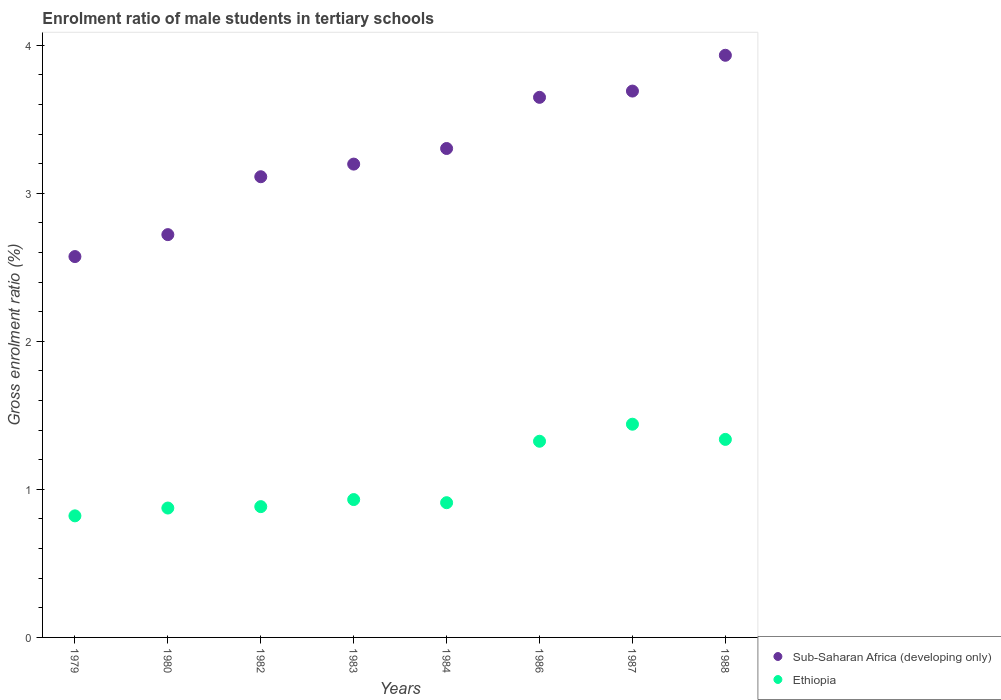How many different coloured dotlines are there?
Provide a short and direct response. 2. What is the enrolment ratio of male students in tertiary schools in Sub-Saharan Africa (developing only) in 1980?
Give a very brief answer. 2.72. Across all years, what is the maximum enrolment ratio of male students in tertiary schools in Sub-Saharan Africa (developing only)?
Keep it short and to the point. 3.93. Across all years, what is the minimum enrolment ratio of male students in tertiary schools in Ethiopia?
Offer a very short reply. 0.82. In which year was the enrolment ratio of male students in tertiary schools in Sub-Saharan Africa (developing only) maximum?
Your answer should be compact. 1988. In which year was the enrolment ratio of male students in tertiary schools in Ethiopia minimum?
Your response must be concise. 1979. What is the total enrolment ratio of male students in tertiary schools in Sub-Saharan Africa (developing only) in the graph?
Give a very brief answer. 26.18. What is the difference between the enrolment ratio of male students in tertiary schools in Sub-Saharan Africa (developing only) in 1980 and that in 1986?
Provide a succinct answer. -0.93. What is the difference between the enrolment ratio of male students in tertiary schools in Ethiopia in 1980 and the enrolment ratio of male students in tertiary schools in Sub-Saharan Africa (developing only) in 1982?
Ensure brevity in your answer.  -2.24. What is the average enrolment ratio of male students in tertiary schools in Sub-Saharan Africa (developing only) per year?
Ensure brevity in your answer.  3.27. In the year 1986, what is the difference between the enrolment ratio of male students in tertiary schools in Sub-Saharan Africa (developing only) and enrolment ratio of male students in tertiary schools in Ethiopia?
Give a very brief answer. 2.32. What is the ratio of the enrolment ratio of male students in tertiary schools in Sub-Saharan Africa (developing only) in 1980 to that in 1986?
Provide a succinct answer. 0.75. Is the difference between the enrolment ratio of male students in tertiary schools in Sub-Saharan Africa (developing only) in 1983 and 1987 greater than the difference between the enrolment ratio of male students in tertiary schools in Ethiopia in 1983 and 1987?
Provide a succinct answer. Yes. What is the difference between the highest and the second highest enrolment ratio of male students in tertiary schools in Ethiopia?
Give a very brief answer. 0.1. What is the difference between the highest and the lowest enrolment ratio of male students in tertiary schools in Sub-Saharan Africa (developing only)?
Offer a terse response. 1.36. Does the enrolment ratio of male students in tertiary schools in Sub-Saharan Africa (developing only) monotonically increase over the years?
Offer a very short reply. Yes. Is the enrolment ratio of male students in tertiary schools in Ethiopia strictly greater than the enrolment ratio of male students in tertiary schools in Sub-Saharan Africa (developing only) over the years?
Offer a terse response. No. How many dotlines are there?
Provide a succinct answer. 2. How many years are there in the graph?
Ensure brevity in your answer.  8. What is the difference between two consecutive major ticks on the Y-axis?
Provide a succinct answer. 1. Does the graph contain any zero values?
Keep it short and to the point. No. Does the graph contain grids?
Offer a very short reply. No. Where does the legend appear in the graph?
Provide a short and direct response. Bottom right. How many legend labels are there?
Offer a very short reply. 2. How are the legend labels stacked?
Keep it short and to the point. Vertical. What is the title of the graph?
Ensure brevity in your answer.  Enrolment ratio of male students in tertiary schools. Does "Cuba" appear as one of the legend labels in the graph?
Offer a terse response. No. What is the label or title of the X-axis?
Your answer should be very brief. Years. What is the Gross enrolment ratio (%) in Sub-Saharan Africa (developing only) in 1979?
Ensure brevity in your answer.  2.57. What is the Gross enrolment ratio (%) in Ethiopia in 1979?
Provide a short and direct response. 0.82. What is the Gross enrolment ratio (%) of Sub-Saharan Africa (developing only) in 1980?
Provide a short and direct response. 2.72. What is the Gross enrolment ratio (%) of Ethiopia in 1980?
Make the answer very short. 0.87. What is the Gross enrolment ratio (%) of Sub-Saharan Africa (developing only) in 1982?
Your answer should be compact. 3.11. What is the Gross enrolment ratio (%) of Ethiopia in 1982?
Offer a terse response. 0.88. What is the Gross enrolment ratio (%) in Sub-Saharan Africa (developing only) in 1983?
Keep it short and to the point. 3.2. What is the Gross enrolment ratio (%) in Ethiopia in 1983?
Your response must be concise. 0.93. What is the Gross enrolment ratio (%) in Sub-Saharan Africa (developing only) in 1984?
Ensure brevity in your answer.  3.3. What is the Gross enrolment ratio (%) of Ethiopia in 1984?
Your answer should be very brief. 0.91. What is the Gross enrolment ratio (%) in Sub-Saharan Africa (developing only) in 1986?
Ensure brevity in your answer.  3.65. What is the Gross enrolment ratio (%) of Ethiopia in 1986?
Offer a very short reply. 1.33. What is the Gross enrolment ratio (%) of Sub-Saharan Africa (developing only) in 1987?
Ensure brevity in your answer.  3.69. What is the Gross enrolment ratio (%) in Ethiopia in 1987?
Give a very brief answer. 1.44. What is the Gross enrolment ratio (%) of Sub-Saharan Africa (developing only) in 1988?
Offer a very short reply. 3.93. What is the Gross enrolment ratio (%) of Ethiopia in 1988?
Keep it short and to the point. 1.34. Across all years, what is the maximum Gross enrolment ratio (%) of Sub-Saharan Africa (developing only)?
Provide a succinct answer. 3.93. Across all years, what is the maximum Gross enrolment ratio (%) in Ethiopia?
Offer a terse response. 1.44. Across all years, what is the minimum Gross enrolment ratio (%) of Sub-Saharan Africa (developing only)?
Ensure brevity in your answer.  2.57. Across all years, what is the minimum Gross enrolment ratio (%) of Ethiopia?
Give a very brief answer. 0.82. What is the total Gross enrolment ratio (%) in Sub-Saharan Africa (developing only) in the graph?
Offer a very short reply. 26.18. What is the total Gross enrolment ratio (%) of Ethiopia in the graph?
Offer a terse response. 8.52. What is the difference between the Gross enrolment ratio (%) of Sub-Saharan Africa (developing only) in 1979 and that in 1980?
Offer a very short reply. -0.15. What is the difference between the Gross enrolment ratio (%) of Ethiopia in 1979 and that in 1980?
Offer a very short reply. -0.05. What is the difference between the Gross enrolment ratio (%) of Sub-Saharan Africa (developing only) in 1979 and that in 1982?
Provide a succinct answer. -0.54. What is the difference between the Gross enrolment ratio (%) in Ethiopia in 1979 and that in 1982?
Offer a terse response. -0.06. What is the difference between the Gross enrolment ratio (%) in Sub-Saharan Africa (developing only) in 1979 and that in 1983?
Keep it short and to the point. -0.62. What is the difference between the Gross enrolment ratio (%) of Ethiopia in 1979 and that in 1983?
Ensure brevity in your answer.  -0.11. What is the difference between the Gross enrolment ratio (%) of Sub-Saharan Africa (developing only) in 1979 and that in 1984?
Give a very brief answer. -0.73. What is the difference between the Gross enrolment ratio (%) of Ethiopia in 1979 and that in 1984?
Provide a short and direct response. -0.09. What is the difference between the Gross enrolment ratio (%) of Sub-Saharan Africa (developing only) in 1979 and that in 1986?
Provide a short and direct response. -1.08. What is the difference between the Gross enrolment ratio (%) in Ethiopia in 1979 and that in 1986?
Offer a terse response. -0.5. What is the difference between the Gross enrolment ratio (%) of Sub-Saharan Africa (developing only) in 1979 and that in 1987?
Offer a very short reply. -1.12. What is the difference between the Gross enrolment ratio (%) of Ethiopia in 1979 and that in 1987?
Give a very brief answer. -0.62. What is the difference between the Gross enrolment ratio (%) in Sub-Saharan Africa (developing only) in 1979 and that in 1988?
Ensure brevity in your answer.  -1.36. What is the difference between the Gross enrolment ratio (%) of Ethiopia in 1979 and that in 1988?
Offer a terse response. -0.52. What is the difference between the Gross enrolment ratio (%) of Sub-Saharan Africa (developing only) in 1980 and that in 1982?
Ensure brevity in your answer.  -0.39. What is the difference between the Gross enrolment ratio (%) in Ethiopia in 1980 and that in 1982?
Provide a succinct answer. -0.01. What is the difference between the Gross enrolment ratio (%) of Sub-Saharan Africa (developing only) in 1980 and that in 1983?
Your answer should be compact. -0.48. What is the difference between the Gross enrolment ratio (%) of Ethiopia in 1980 and that in 1983?
Give a very brief answer. -0.06. What is the difference between the Gross enrolment ratio (%) in Sub-Saharan Africa (developing only) in 1980 and that in 1984?
Keep it short and to the point. -0.58. What is the difference between the Gross enrolment ratio (%) of Ethiopia in 1980 and that in 1984?
Give a very brief answer. -0.04. What is the difference between the Gross enrolment ratio (%) in Sub-Saharan Africa (developing only) in 1980 and that in 1986?
Keep it short and to the point. -0.93. What is the difference between the Gross enrolment ratio (%) in Ethiopia in 1980 and that in 1986?
Ensure brevity in your answer.  -0.45. What is the difference between the Gross enrolment ratio (%) of Sub-Saharan Africa (developing only) in 1980 and that in 1987?
Your answer should be very brief. -0.97. What is the difference between the Gross enrolment ratio (%) in Ethiopia in 1980 and that in 1987?
Your response must be concise. -0.57. What is the difference between the Gross enrolment ratio (%) of Sub-Saharan Africa (developing only) in 1980 and that in 1988?
Ensure brevity in your answer.  -1.21. What is the difference between the Gross enrolment ratio (%) of Ethiopia in 1980 and that in 1988?
Offer a terse response. -0.46. What is the difference between the Gross enrolment ratio (%) of Sub-Saharan Africa (developing only) in 1982 and that in 1983?
Provide a short and direct response. -0.09. What is the difference between the Gross enrolment ratio (%) of Ethiopia in 1982 and that in 1983?
Ensure brevity in your answer.  -0.05. What is the difference between the Gross enrolment ratio (%) of Sub-Saharan Africa (developing only) in 1982 and that in 1984?
Your answer should be compact. -0.19. What is the difference between the Gross enrolment ratio (%) of Ethiopia in 1982 and that in 1984?
Keep it short and to the point. -0.03. What is the difference between the Gross enrolment ratio (%) of Sub-Saharan Africa (developing only) in 1982 and that in 1986?
Offer a very short reply. -0.54. What is the difference between the Gross enrolment ratio (%) in Ethiopia in 1982 and that in 1986?
Provide a succinct answer. -0.44. What is the difference between the Gross enrolment ratio (%) in Sub-Saharan Africa (developing only) in 1982 and that in 1987?
Provide a succinct answer. -0.58. What is the difference between the Gross enrolment ratio (%) of Ethiopia in 1982 and that in 1987?
Provide a short and direct response. -0.56. What is the difference between the Gross enrolment ratio (%) in Sub-Saharan Africa (developing only) in 1982 and that in 1988?
Your answer should be compact. -0.82. What is the difference between the Gross enrolment ratio (%) of Ethiopia in 1982 and that in 1988?
Keep it short and to the point. -0.45. What is the difference between the Gross enrolment ratio (%) in Sub-Saharan Africa (developing only) in 1983 and that in 1984?
Provide a short and direct response. -0.11. What is the difference between the Gross enrolment ratio (%) of Ethiopia in 1983 and that in 1984?
Your answer should be very brief. 0.02. What is the difference between the Gross enrolment ratio (%) of Sub-Saharan Africa (developing only) in 1983 and that in 1986?
Give a very brief answer. -0.45. What is the difference between the Gross enrolment ratio (%) in Ethiopia in 1983 and that in 1986?
Your answer should be very brief. -0.39. What is the difference between the Gross enrolment ratio (%) in Sub-Saharan Africa (developing only) in 1983 and that in 1987?
Provide a short and direct response. -0.49. What is the difference between the Gross enrolment ratio (%) of Ethiopia in 1983 and that in 1987?
Provide a short and direct response. -0.51. What is the difference between the Gross enrolment ratio (%) of Sub-Saharan Africa (developing only) in 1983 and that in 1988?
Provide a short and direct response. -0.74. What is the difference between the Gross enrolment ratio (%) of Ethiopia in 1983 and that in 1988?
Ensure brevity in your answer.  -0.41. What is the difference between the Gross enrolment ratio (%) in Sub-Saharan Africa (developing only) in 1984 and that in 1986?
Your answer should be compact. -0.35. What is the difference between the Gross enrolment ratio (%) of Ethiopia in 1984 and that in 1986?
Give a very brief answer. -0.42. What is the difference between the Gross enrolment ratio (%) in Sub-Saharan Africa (developing only) in 1984 and that in 1987?
Your answer should be very brief. -0.39. What is the difference between the Gross enrolment ratio (%) in Ethiopia in 1984 and that in 1987?
Keep it short and to the point. -0.53. What is the difference between the Gross enrolment ratio (%) of Sub-Saharan Africa (developing only) in 1984 and that in 1988?
Make the answer very short. -0.63. What is the difference between the Gross enrolment ratio (%) in Ethiopia in 1984 and that in 1988?
Your answer should be very brief. -0.43. What is the difference between the Gross enrolment ratio (%) of Sub-Saharan Africa (developing only) in 1986 and that in 1987?
Give a very brief answer. -0.04. What is the difference between the Gross enrolment ratio (%) of Ethiopia in 1986 and that in 1987?
Your answer should be very brief. -0.12. What is the difference between the Gross enrolment ratio (%) in Sub-Saharan Africa (developing only) in 1986 and that in 1988?
Offer a very short reply. -0.28. What is the difference between the Gross enrolment ratio (%) of Ethiopia in 1986 and that in 1988?
Your answer should be compact. -0.01. What is the difference between the Gross enrolment ratio (%) of Sub-Saharan Africa (developing only) in 1987 and that in 1988?
Provide a succinct answer. -0.24. What is the difference between the Gross enrolment ratio (%) in Ethiopia in 1987 and that in 1988?
Offer a very short reply. 0.1. What is the difference between the Gross enrolment ratio (%) in Sub-Saharan Africa (developing only) in 1979 and the Gross enrolment ratio (%) in Ethiopia in 1980?
Your response must be concise. 1.7. What is the difference between the Gross enrolment ratio (%) of Sub-Saharan Africa (developing only) in 1979 and the Gross enrolment ratio (%) of Ethiopia in 1982?
Make the answer very short. 1.69. What is the difference between the Gross enrolment ratio (%) of Sub-Saharan Africa (developing only) in 1979 and the Gross enrolment ratio (%) of Ethiopia in 1983?
Provide a short and direct response. 1.64. What is the difference between the Gross enrolment ratio (%) in Sub-Saharan Africa (developing only) in 1979 and the Gross enrolment ratio (%) in Ethiopia in 1984?
Keep it short and to the point. 1.66. What is the difference between the Gross enrolment ratio (%) of Sub-Saharan Africa (developing only) in 1979 and the Gross enrolment ratio (%) of Ethiopia in 1986?
Provide a short and direct response. 1.25. What is the difference between the Gross enrolment ratio (%) in Sub-Saharan Africa (developing only) in 1979 and the Gross enrolment ratio (%) in Ethiopia in 1987?
Provide a succinct answer. 1.13. What is the difference between the Gross enrolment ratio (%) of Sub-Saharan Africa (developing only) in 1979 and the Gross enrolment ratio (%) of Ethiopia in 1988?
Your response must be concise. 1.23. What is the difference between the Gross enrolment ratio (%) in Sub-Saharan Africa (developing only) in 1980 and the Gross enrolment ratio (%) in Ethiopia in 1982?
Provide a short and direct response. 1.84. What is the difference between the Gross enrolment ratio (%) in Sub-Saharan Africa (developing only) in 1980 and the Gross enrolment ratio (%) in Ethiopia in 1983?
Ensure brevity in your answer.  1.79. What is the difference between the Gross enrolment ratio (%) in Sub-Saharan Africa (developing only) in 1980 and the Gross enrolment ratio (%) in Ethiopia in 1984?
Your response must be concise. 1.81. What is the difference between the Gross enrolment ratio (%) in Sub-Saharan Africa (developing only) in 1980 and the Gross enrolment ratio (%) in Ethiopia in 1986?
Provide a short and direct response. 1.4. What is the difference between the Gross enrolment ratio (%) of Sub-Saharan Africa (developing only) in 1980 and the Gross enrolment ratio (%) of Ethiopia in 1987?
Give a very brief answer. 1.28. What is the difference between the Gross enrolment ratio (%) in Sub-Saharan Africa (developing only) in 1980 and the Gross enrolment ratio (%) in Ethiopia in 1988?
Your answer should be compact. 1.38. What is the difference between the Gross enrolment ratio (%) of Sub-Saharan Africa (developing only) in 1982 and the Gross enrolment ratio (%) of Ethiopia in 1983?
Provide a short and direct response. 2.18. What is the difference between the Gross enrolment ratio (%) in Sub-Saharan Africa (developing only) in 1982 and the Gross enrolment ratio (%) in Ethiopia in 1984?
Provide a succinct answer. 2.2. What is the difference between the Gross enrolment ratio (%) of Sub-Saharan Africa (developing only) in 1982 and the Gross enrolment ratio (%) of Ethiopia in 1986?
Keep it short and to the point. 1.79. What is the difference between the Gross enrolment ratio (%) in Sub-Saharan Africa (developing only) in 1982 and the Gross enrolment ratio (%) in Ethiopia in 1987?
Keep it short and to the point. 1.67. What is the difference between the Gross enrolment ratio (%) of Sub-Saharan Africa (developing only) in 1982 and the Gross enrolment ratio (%) of Ethiopia in 1988?
Give a very brief answer. 1.77. What is the difference between the Gross enrolment ratio (%) in Sub-Saharan Africa (developing only) in 1983 and the Gross enrolment ratio (%) in Ethiopia in 1984?
Provide a succinct answer. 2.29. What is the difference between the Gross enrolment ratio (%) of Sub-Saharan Africa (developing only) in 1983 and the Gross enrolment ratio (%) of Ethiopia in 1986?
Offer a terse response. 1.87. What is the difference between the Gross enrolment ratio (%) of Sub-Saharan Africa (developing only) in 1983 and the Gross enrolment ratio (%) of Ethiopia in 1987?
Offer a very short reply. 1.76. What is the difference between the Gross enrolment ratio (%) of Sub-Saharan Africa (developing only) in 1983 and the Gross enrolment ratio (%) of Ethiopia in 1988?
Offer a terse response. 1.86. What is the difference between the Gross enrolment ratio (%) in Sub-Saharan Africa (developing only) in 1984 and the Gross enrolment ratio (%) in Ethiopia in 1986?
Ensure brevity in your answer.  1.98. What is the difference between the Gross enrolment ratio (%) of Sub-Saharan Africa (developing only) in 1984 and the Gross enrolment ratio (%) of Ethiopia in 1987?
Make the answer very short. 1.86. What is the difference between the Gross enrolment ratio (%) in Sub-Saharan Africa (developing only) in 1984 and the Gross enrolment ratio (%) in Ethiopia in 1988?
Offer a very short reply. 1.96. What is the difference between the Gross enrolment ratio (%) in Sub-Saharan Africa (developing only) in 1986 and the Gross enrolment ratio (%) in Ethiopia in 1987?
Offer a very short reply. 2.21. What is the difference between the Gross enrolment ratio (%) in Sub-Saharan Africa (developing only) in 1986 and the Gross enrolment ratio (%) in Ethiopia in 1988?
Offer a terse response. 2.31. What is the difference between the Gross enrolment ratio (%) of Sub-Saharan Africa (developing only) in 1987 and the Gross enrolment ratio (%) of Ethiopia in 1988?
Make the answer very short. 2.35. What is the average Gross enrolment ratio (%) of Sub-Saharan Africa (developing only) per year?
Provide a succinct answer. 3.27. What is the average Gross enrolment ratio (%) of Ethiopia per year?
Offer a terse response. 1.07. In the year 1979, what is the difference between the Gross enrolment ratio (%) in Sub-Saharan Africa (developing only) and Gross enrolment ratio (%) in Ethiopia?
Keep it short and to the point. 1.75. In the year 1980, what is the difference between the Gross enrolment ratio (%) in Sub-Saharan Africa (developing only) and Gross enrolment ratio (%) in Ethiopia?
Provide a succinct answer. 1.85. In the year 1982, what is the difference between the Gross enrolment ratio (%) in Sub-Saharan Africa (developing only) and Gross enrolment ratio (%) in Ethiopia?
Make the answer very short. 2.23. In the year 1983, what is the difference between the Gross enrolment ratio (%) in Sub-Saharan Africa (developing only) and Gross enrolment ratio (%) in Ethiopia?
Offer a very short reply. 2.27. In the year 1984, what is the difference between the Gross enrolment ratio (%) in Sub-Saharan Africa (developing only) and Gross enrolment ratio (%) in Ethiopia?
Give a very brief answer. 2.39. In the year 1986, what is the difference between the Gross enrolment ratio (%) in Sub-Saharan Africa (developing only) and Gross enrolment ratio (%) in Ethiopia?
Your answer should be very brief. 2.32. In the year 1987, what is the difference between the Gross enrolment ratio (%) of Sub-Saharan Africa (developing only) and Gross enrolment ratio (%) of Ethiopia?
Make the answer very short. 2.25. In the year 1988, what is the difference between the Gross enrolment ratio (%) of Sub-Saharan Africa (developing only) and Gross enrolment ratio (%) of Ethiopia?
Your response must be concise. 2.59. What is the ratio of the Gross enrolment ratio (%) in Sub-Saharan Africa (developing only) in 1979 to that in 1980?
Ensure brevity in your answer.  0.95. What is the ratio of the Gross enrolment ratio (%) of Ethiopia in 1979 to that in 1980?
Provide a short and direct response. 0.94. What is the ratio of the Gross enrolment ratio (%) of Sub-Saharan Africa (developing only) in 1979 to that in 1982?
Give a very brief answer. 0.83. What is the ratio of the Gross enrolment ratio (%) of Ethiopia in 1979 to that in 1982?
Give a very brief answer. 0.93. What is the ratio of the Gross enrolment ratio (%) of Sub-Saharan Africa (developing only) in 1979 to that in 1983?
Your answer should be compact. 0.8. What is the ratio of the Gross enrolment ratio (%) in Ethiopia in 1979 to that in 1983?
Your answer should be compact. 0.88. What is the ratio of the Gross enrolment ratio (%) in Sub-Saharan Africa (developing only) in 1979 to that in 1984?
Ensure brevity in your answer.  0.78. What is the ratio of the Gross enrolment ratio (%) in Ethiopia in 1979 to that in 1984?
Your answer should be compact. 0.9. What is the ratio of the Gross enrolment ratio (%) of Sub-Saharan Africa (developing only) in 1979 to that in 1986?
Your response must be concise. 0.71. What is the ratio of the Gross enrolment ratio (%) of Ethiopia in 1979 to that in 1986?
Your answer should be compact. 0.62. What is the ratio of the Gross enrolment ratio (%) in Sub-Saharan Africa (developing only) in 1979 to that in 1987?
Give a very brief answer. 0.7. What is the ratio of the Gross enrolment ratio (%) in Ethiopia in 1979 to that in 1987?
Offer a very short reply. 0.57. What is the ratio of the Gross enrolment ratio (%) of Sub-Saharan Africa (developing only) in 1979 to that in 1988?
Ensure brevity in your answer.  0.65. What is the ratio of the Gross enrolment ratio (%) in Ethiopia in 1979 to that in 1988?
Offer a very short reply. 0.61. What is the ratio of the Gross enrolment ratio (%) in Sub-Saharan Africa (developing only) in 1980 to that in 1982?
Offer a very short reply. 0.87. What is the ratio of the Gross enrolment ratio (%) in Ethiopia in 1980 to that in 1982?
Your response must be concise. 0.99. What is the ratio of the Gross enrolment ratio (%) in Sub-Saharan Africa (developing only) in 1980 to that in 1983?
Offer a terse response. 0.85. What is the ratio of the Gross enrolment ratio (%) of Ethiopia in 1980 to that in 1983?
Provide a succinct answer. 0.94. What is the ratio of the Gross enrolment ratio (%) in Sub-Saharan Africa (developing only) in 1980 to that in 1984?
Your response must be concise. 0.82. What is the ratio of the Gross enrolment ratio (%) in Ethiopia in 1980 to that in 1984?
Provide a succinct answer. 0.96. What is the ratio of the Gross enrolment ratio (%) in Sub-Saharan Africa (developing only) in 1980 to that in 1986?
Keep it short and to the point. 0.75. What is the ratio of the Gross enrolment ratio (%) of Ethiopia in 1980 to that in 1986?
Give a very brief answer. 0.66. What is the ratio of the Gross enrolment ratio (%) in Sub-Saharan Africa (developing only) in 1980 to that in 1987?
Offer a very short reply. 0.74. What is the ratio of the Gross enrolment ratio (%) of Ethiopia in 1980 to that in 1987?
Your answer should be very brief. 0.61. What is the ratio of the Gross enrolment ratio (%) in Sub-Saharan Africa (developing only) in 1980 to that in 1988?
Provide a short and direct response. 0.69. What is the ratio of the Gross enrolment ratio (%) in Ethiopia in 1980 to that in 1988?
Your response must be concise. 0.65. What is the ratio of the Gross enrolment ratio (%) of Sub-Saharan Africa (developing only) in 1982 to that in 1983?
Give a very brief answer. 0.97. What is the ratio of the Gross enrolment ratio (%) of Ethiopia in 1982 to that in 1983?
Your response must be concise. 0.95. What is the ratio of the Gross enrolment ratio (%) of Sub-Saharan Africa (developing only) in 1982 to that in 1984?
Provide a short and direct response. 0.94. What is the ratio of the Gross enrolment ratio (%) of Ethiopia in 1982 to that in 1984?
Ensure brevity in your answer.  0.97. What is the ratio of the Gross enrolment ratio (%) in Sub-Saharan Africa (developing only) in 1982 to that in 1986?
Ensure brevity in your answer.  0.85. What is the ratio of the Gross enrolment ratio (%) of Sub-Saharan Africa (developing only) in 1982 to that in 1987?
Make the answer very short. 0.84. What is the ratio of the Gross enrolment ratio (%) of Ethiopia in 1982 to that in 1987?
Offer a very short reply. 0.61. What is the ratio of the Gross enrolment ratio (%) of Sub-Saharan Africa (developing only) in 1982 to that in 1988?
Ensure brevity in your answer.  0.79. What is the ratio of the Gross enrolment ratio (%) of Ethiopia in 1982 to that in 1988?
Offer a terse response. 0.66. What is the ratio of the Gross enrolment ratio (%) of Sub-Saharan Africa (developing only) in 1983 to that in 1984?
Give a very brief answer. 0.97. What is the ratio of the Gross enrolment ratio (%) of Ethiopia in 1983 to that in 1984?
Your answer should be compact. 1.02. What is the ratio of the Gross enrolment ratio (%) of Sub-Saharan Africa (developing only) in 1983 to that in 1986?
Make the answer very short. 0.88. What is the ratio of the Gross enrolment ratio (%) of Ethiopia in 1983 to that in 1986?
Your answer should be very brief. 0.7. What is the ratio of the Gross enrolment ratio (%) of Sub-Saharan Africa (developing only) in 1983 to that in 1987?
Your answer should be very brief. 0.87. What is the ratio of the Gross enrolment ratio (%) in Ethiopia in 1983 to that in 1987?
Keep it short and to the point. 0.65. What is the ratio of the Gross enrolment ratio (%) of Sub-Saharan Africa (developing only) in 1983 to that in 1988?
Make the answer very short. 0.81. What is the ratio of the Gross enrolment ratio (%) of Ethiopia in 1983 to that in 1988?
Make the answer very short. 0.7. What is the ratio of the Gross enrolment ratio (%) of Sub-Saharan Africa (developing only) in 1984 to that in 1986?
Provide a succinct answer. 0.91. What is the ratio of the Gross enrolment ratio (%) in Ethiopia in 1984 to that in 1986?
Provide a succinct answer. 0.69. What is the ratio of the Gross enrolment ratio (%) in Sub-Saharan Africa (developing only) in 1984 to that in 1987?
Ensure brevity in your answer.  0.89. What is the ratio of the Gross enrolment ratio (%) in Ethiopia in 1984 to that in 1987?
Offer a very short reply. 0.63. What is the ratio of the Gross enrolment ratio (%) of Sub-Saharan Africa (developing only) in 1984 to that in 1988?
Your answer should be very brief. 0.84. What is the ratio of the Gross enrolment ratio (%) in Ethiopia in 1984 to that in 1988?
Make the answer very short. 0.68. What is the ratio of the Gross enrolment ratio (%) of Ethiopia in 1986 to that in 1987?
Your answer should be compact. 0.92. What is the ratio of the Gross enrolment ratio (%) in Sub-Saharan Africa (developing only) in 1986 to that in 1988?
Offer a terse response. 0.93. What is the ratio of the Gross enrolment ratio (%) of Ethiopia in 1986 to that in 1988?
Your answer should be compact. 0.99. What is the ratio of the Gross enrolment ratio (%) in Sub-Saharan Africa (developing only) in 1987 to that in 1988?
Give a very brief answer. 0.94. What is the ratio of the Gross enrolment ratio (%) in Ethiopia in 1987 to that in 1988?
Your answer should be very brief. 1.08. What is the difference between the highest and the second highest Gross enrolment ratio (%) in Sub-Saharan Africa (developing only)?
Ensure brevity in your answer.  0.24. What is the difference between the highest and the second highest Gross enrolment ratio (%) in Ethiopia?
Make the answer very short. 0.1. What is the difference between the highest and the lowest Gross enrolment ratio (%) of Sub-Saharan Africa (developing only)?
Your answer should be very brief. 1.36. What is the difference between the highest and the lowest Gross enrolment ratio (%) of Ethiopia?
Your answer should be very brief. 0.62. 